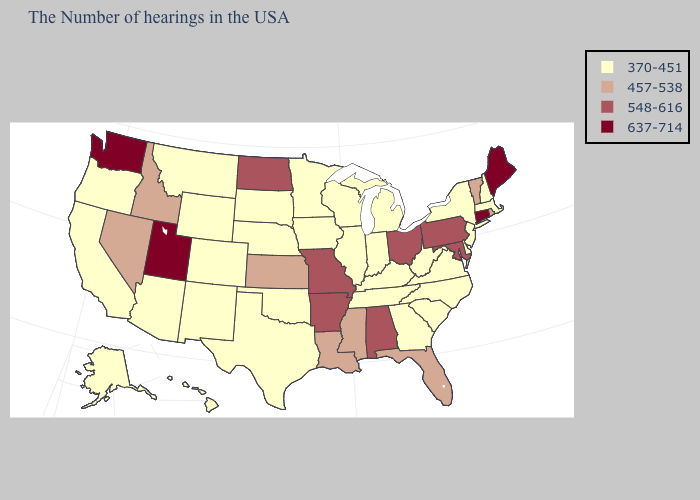Among the states that border Washington , does Oregon have the highest value?
Concise answer only. No. Does Ohio have the highest value in the MidWest?
Answer briefly. Yes. What is the value of Alabama?
Give a very brief answer. 548-616. What is the lowest value in the South?
Quick response, please. 370-451. Does Washington have the highest value in the USA?
Give a very brief answer. Yes. What is the highest value in states that border Virginia?
Keep it brief. 548-616. Name the states that have a value in the range 637-714?
Keep it brief. Maine, Connecticut, Utah, Washington. Does Minnesota have a higher value than North Dakota?
Answer briefly. No. What is the value of Montana?
Quick response, please. 370-451. Name the states that have a value in the range 370-451?
Quick response, please. Massachusetts, New Hampshire, New York, New Jersey, Delaware, Virginia, North Carolina, South Carolina, West Virginia, Georgia, Michigan, Kentucky, Indiana, Tennessee, Wisconsin, Illinois, Minnesota, Iowa, Nebraska, Oklahoma, Texas, South Dakota, Wyoming, Colorado, New Mexico, Montana, Arizona, California, Oregon, Alaska, Hawaii. What is the value of Minnesota?
Answer briefly. 370-451. Among the states that border South Dakota , which have the lowest value?
Quick response, please. Minnesota, Iowa, Nebraska, Wyoming, Montana. What is the highest value in the USA?
Keep it brief. 637-714. Which states have the highest value in the USA?
Concise answer only. Maine, Connecticut, Utah, Washington. What is the highest value in states that border Washington?
Answer briefly. 457-538. 